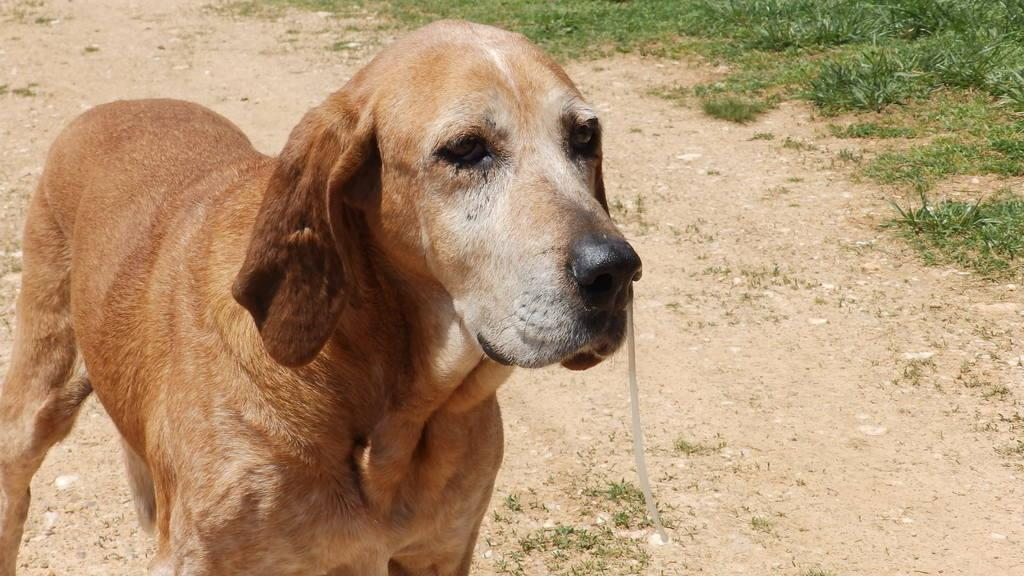Where was the picture taken? The picture was clicked outside. What can be seen on the left side of the image? There is a dog standing on the ground on the left side of the image. What type of vegetation is visible on the right side of the image? There is green grass visible on the right side of the image. What type of chain is the dog holding in the image? There is no chain present in the image; the dog is standing on the ground without any visible restraints. 